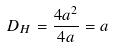Convert formula to latex. <formula><loc_0><loc_0><loc_500><loc_500>D _ { H } = \frac { 4 a ^ { 2 } } { 4 a } = a</formula> 